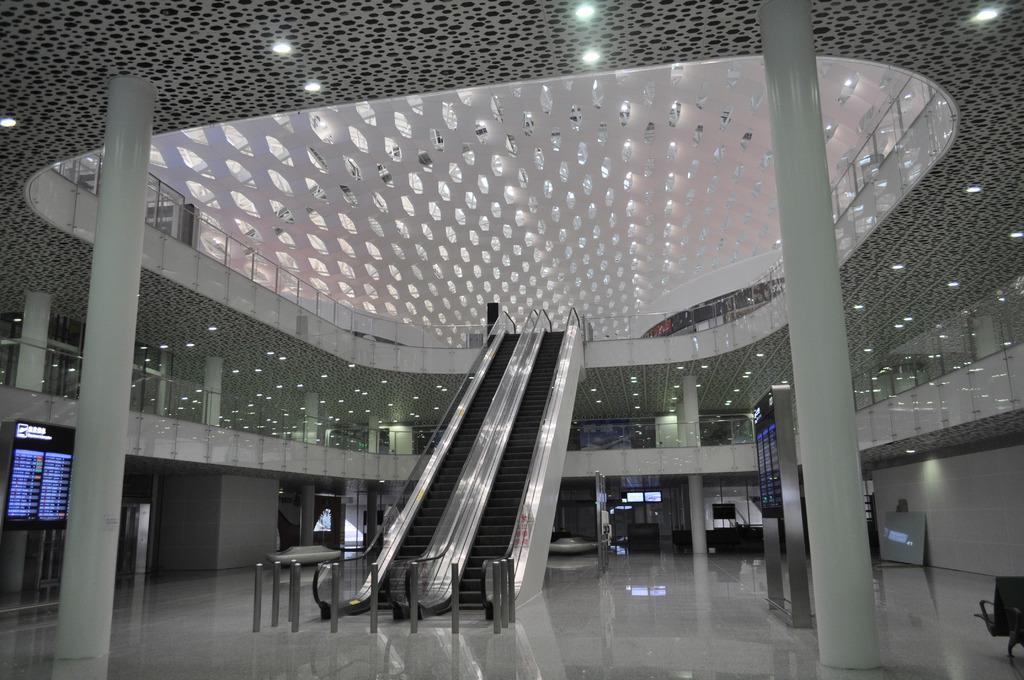In one or two sentences, can you explain what this image depicts? In this picture I can see the inside view of a building. There are chairs, pillars, lights, escalators, screen display boards and some other objects. 